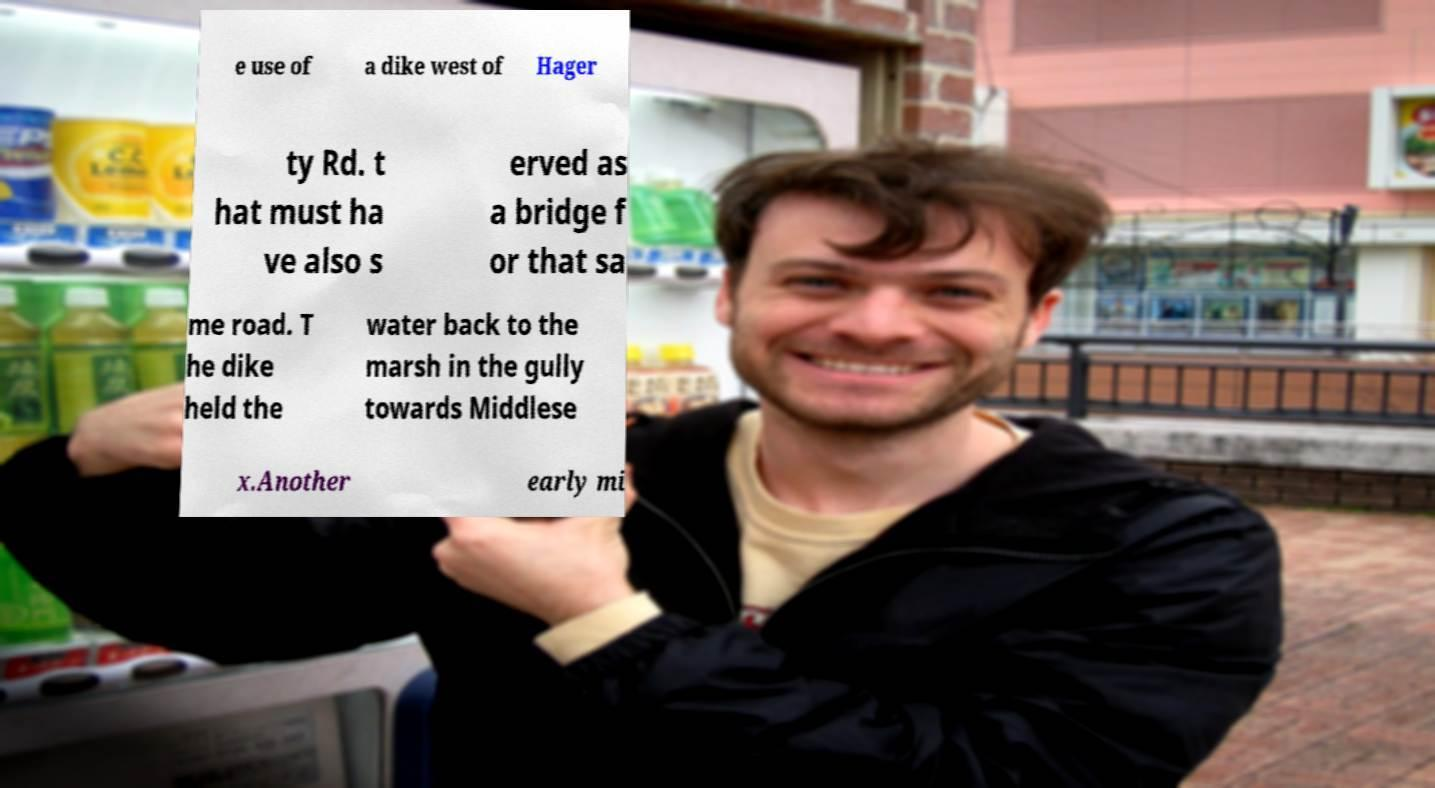Can you accurately transcribe the text from the provided image for me? e use of a dike west of Hager ty Rd. t hat must ha ve also s erved as a bridge f or that sa me road. T he dike held the water back to the marsh in the gully towards Middlese x.Another early mi 